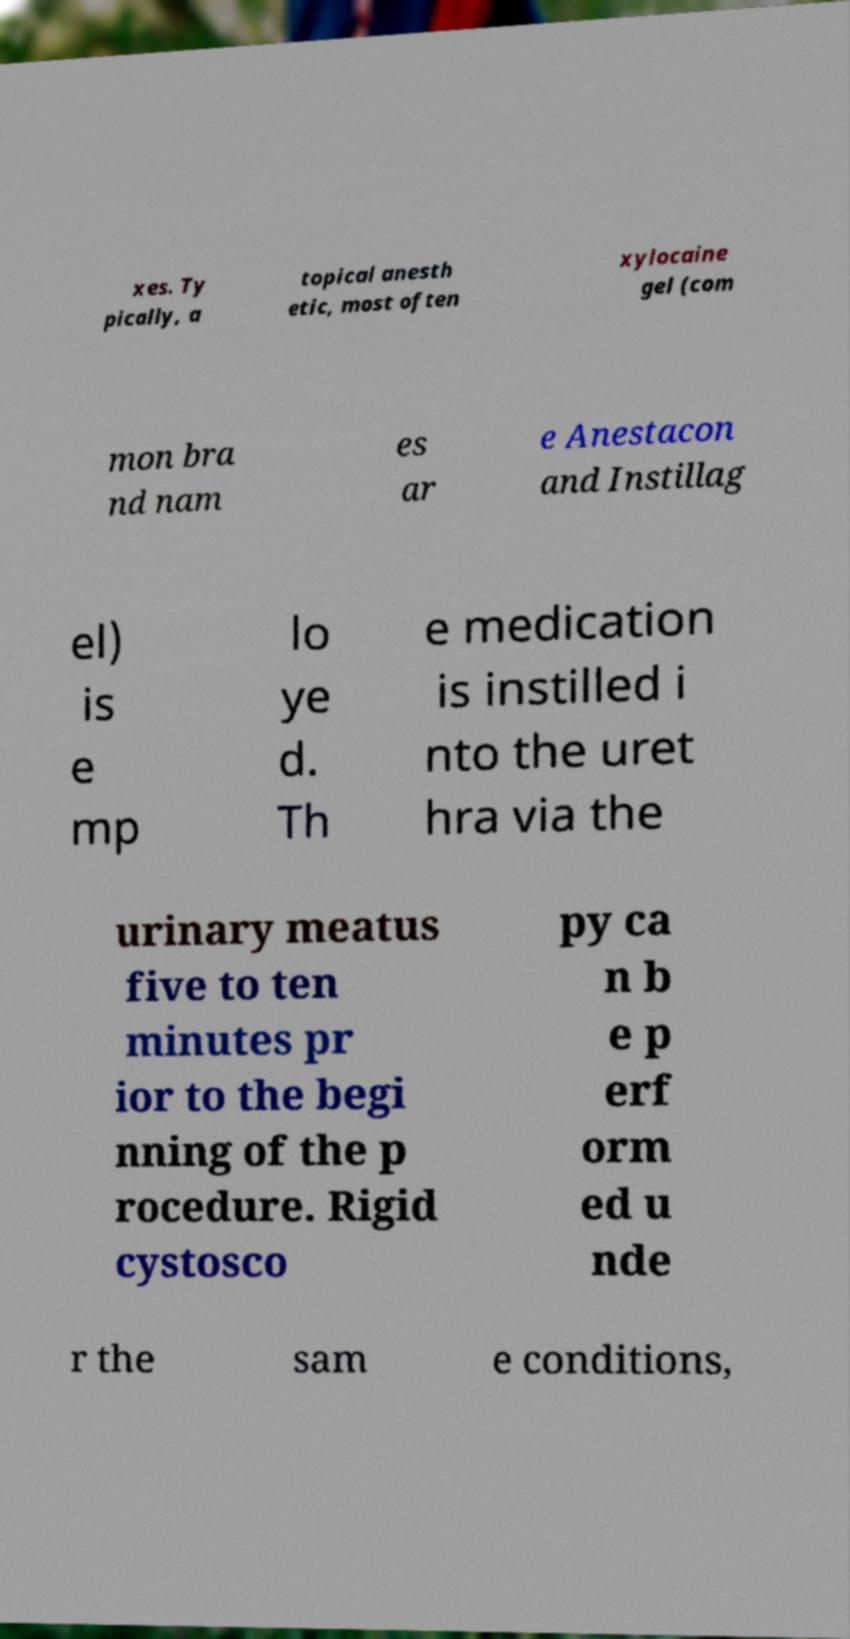I need the written content from this picture converted into text. Can you do that? xes. Ty pically, a topical anesth etic, most often xylocaine gel (com mon bra nd nam es ar e Anestacon and Instillag el) is e mp lo ye d. Th e medication is instilled i nto the uret hra via the urinary meatus five to ten minutes pr ior to the begi nning of the p rocedure. Rigid cystosco py ca n b e p erf orm ed u nde r the sam e conditions, 